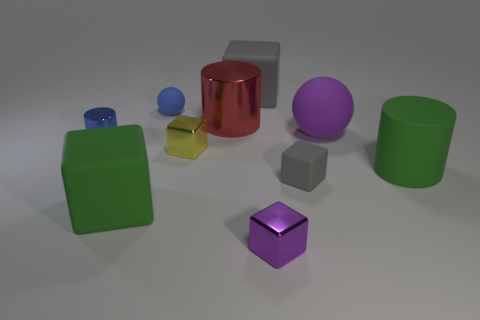What number of cyan things are large rubber cubes or cubes?
Your answer should be very brief. 0. There is a yellow object behind the purple thing in front of the small blue shiny cylinder; what is its shape?
Your answer should be very brief. Cube. There is a gray matte block in front of the big gray block; is it the same size as the ball on the right side of the large gray matte cube?
Offer a terse response. No. Is there a large red ball made of the same material as the purple ball?
Your answer should be compact. No. The cylinder that is the same color as the small sphere is what size?
Make the answer very short. Small. Is there a red metallic object behind the metallic cube in front of the tiny yellow metal cube left of the big purple rubber sphere?
Keep it short and to the point. Yes. Are there any matte blocks on the right side of the purple metallic block?
Your answer should be compact. Yes. There is a small gray matte cube to the right of the tiny ball; what number of tiny blue things are behind it?
Provide a succinct answer. 2. There is a blue rubber object; is its size the same as the gray block that is behind the large red metallic object?
Make the answer very short. No. Is there a thing of the same color as the large rubber cylinder?
Offer a very short reply. Yes. 